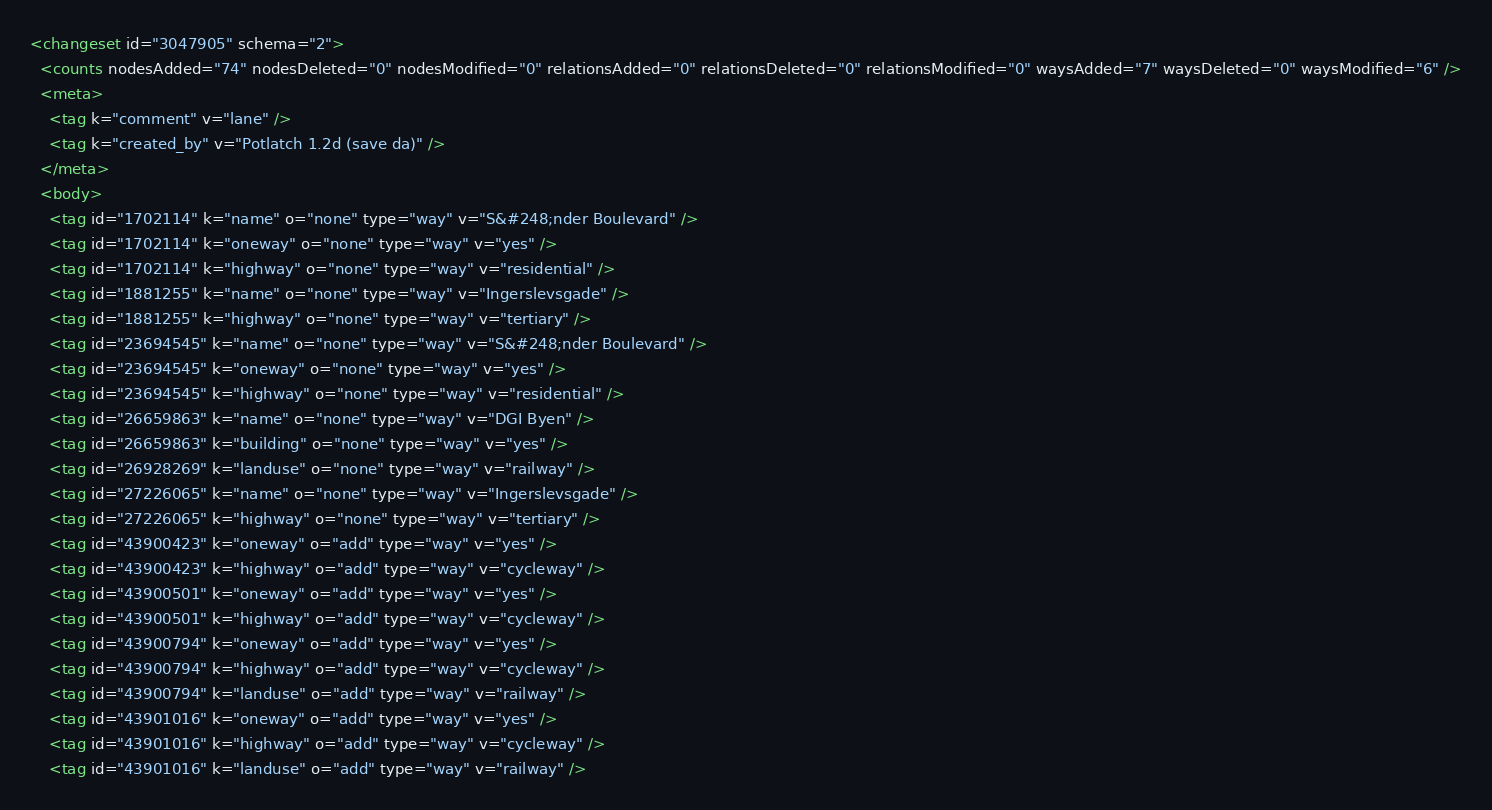<code> <loc_0><loc_0><loc_500><loc_500><_XML_><changeset id="3047905" schema="2">
  <counts nodesAdded="74" nodesDeleted="0" nodesModified="0" relationsAdded="0" relationsDeleted="0" relationsModified="0" waysAdded="7" waysDeleted="0" waysModified="6" />
  <meta>
    <tag k="comment" v="lane" />
    <tag k="created_by" v="Potlatch 1.2d (save da)" />
  </meta>
  <body>
    <tag id="1702114" k="name" o="none" type="way" v="S&#248;nder Boulevard" />
    <tag id="1702114" k="oneway" o="none" type="way" v="yes" />
    <tag id="1702114" k="highway" o="none" type="way" v="residential" />
    <tag id="1881255" k="name" o="none" type="way" v="Ingerslevsgade" />
    <tag id="1881255" k="highway" o="none" type="way" v="tertiary" />
    <tag id="23694545" k="name" o="none" type="way" v="S&#248;nder Boulevard" />
    <tag id="23694545" k="oneway" o="none" type="way" v="yes" />
    <tag id="23694545" k="highway" o="none" type="way" v="residential" />
    <tag id="26659863" k="name" o="none" type="way" v="DGI Byen" />
    <tag id="26659863" k="building" o="none" type="way" v="yes" />
    <tag id="26928269" k="landuse" o="none" type="way" v="railway" />
    <tag id="27226065" k="name" o="none" type="way" v="Ingerslevsgade" />
    <tag id="27226065" k="highway" o="none" type="way" v="tertiary" />
    <tag id="43900423" k="oneway" o="add" type="way" v="yes" />
    <tag id="43900423" k="highway" o="add" type="way" v="cycleway" />
    <tag id="43900501" k="oneway" o="add" type="way" v="yes" />
    <tag id="43900501" k="highway" o="add" type="way" v="cycleway" />
    <tag id="43900794" k="oneway" o="add" type="way" v="yes" />
    <tag id="43900794" k="highway" o="add" type="way" v="cycleway" />
    <tag id="43900794" k="landuse" o="add" type="way" v="railway" />
    <tag id="43901016" k="oneway" o="add" type="way" v="yes" />
    <tag id="43901016" k="highway" o="add" type="way" v="cycleway" />
    <tag id="43901016" k="landuse" o="add" type="way" v="railway" /></code> 